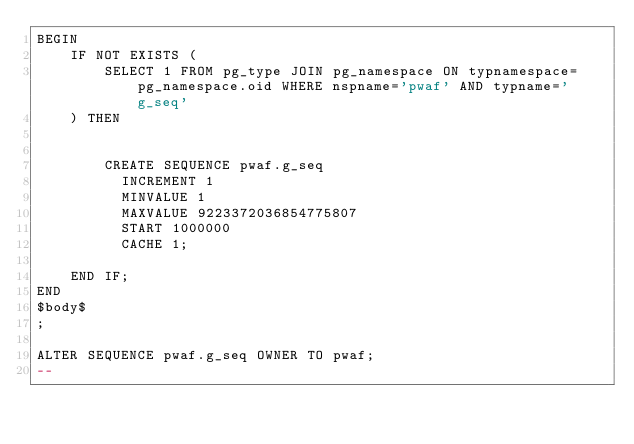<code> <loc_0><loc_0><loc_500><loc_500><_SQL_>BEGIN
	IF NOT EXISTS (
    	SELECT 1 FROM pg_type JOIN pg_namespace ON typnamespace=pg_namespace.oid WHERE nspname='pwaf' AND typname='g_seq'
    ) THEN
    	

		CREATE SEQUENCE pwaf.g_seq
		  INCREMENT 1
		  MINVALUE 1
		  MAXVALUE 9223372036854775807
		  START 1000000
		  CACHE 1;

   	END IF;
END
$body$
;

ALTER SEQUENCE pwaf.g_seq OWNER TO pwaf;
--</code> 